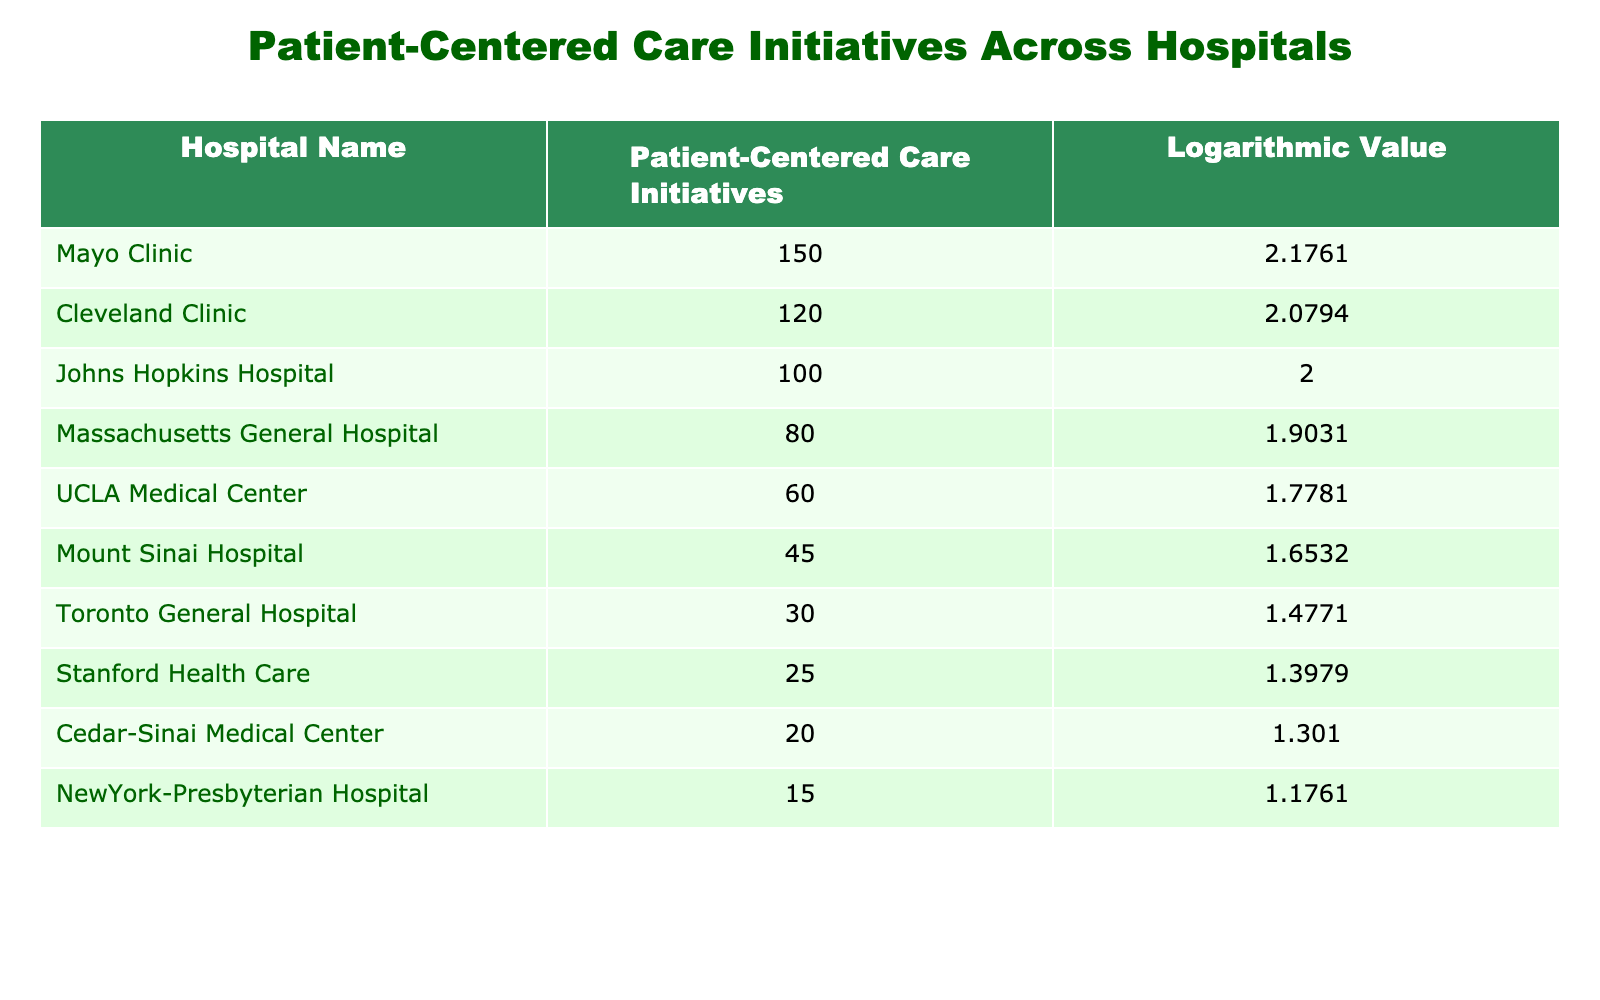What is the highest number of patient-centered care initiatives reported? The highest number in the table is associated with Mayo Clinic, which has reported 150 initiatives.
Answer: 150 Which hospital has the second lowest logarithmic value? The second lowest logarithmic value is for Mount Sinai Hospital, with a value of 1.6532.
Answer: 1.6532 What is the total number of patient-centered care initiatives from the top three hospitals? Adding the initiatives from the top three hospitals: Mayo Clinic (150) + Cleveland Clinic (120) + Johns Hopkins Hospital (100) = 370.
Answer: 370 Is it true that Toronto General Hospital has more initiatives than Cedar-Sinai Medical Center? No, Toronto General Hospital has 30 initiatives, while Cedar-Sinai Medical Center has 20 initiatives.
Answer: No What is the average number of patient-centered care initiatives for hospitals with logarithmic values greater than 1.5? The hospitals with values greater than 1.5 are: Mayo Clinic (150), Cleveland Clinic (120), Johns Hopkins Hospital (100), Massachusetts General Hospital (80), UCLA Medical Center (60), and Mount Sinai Hospital (45). The total is 150 + 120 + 100 + 80 + 60 + 45 = 555, and there are 6 hospitals, so the average is 555/6 = 92.5.
Answer: 92.5 Which hospital has a logarithmic value closest to 1.5? The hospital with the logarithmic value closest to 1.5 is Toronto General Hospital with a value of 1.4771.
Answer: 1.4771 What is the difference in patient-centered care initiatives between the hospital with the most initiatives and the one with the least? The hospital with the most initiatives is Mayo Clinic (150) and the one with the least is NewYork-Presbyterian Hospital (15), so the difference is 150 - 15 = 135.
Answer: 135 Is there a hospital with exactly 25 patient-centered care initiatives? Yes, Stanford Health Care has exactly 25 initiatives.
Answer: Yes What is the combined logarithmic value for the two hospitals with the highest initiatives? The hospitals with the highest initiatives, Mayo Clinic and Cleveland Clinic have logarithmic values of 2.1761 and 2.0794, respectively. The combined logarithmic value is 2.1761 + 2.0794 = 4.2555.
Answer: 4.2555 